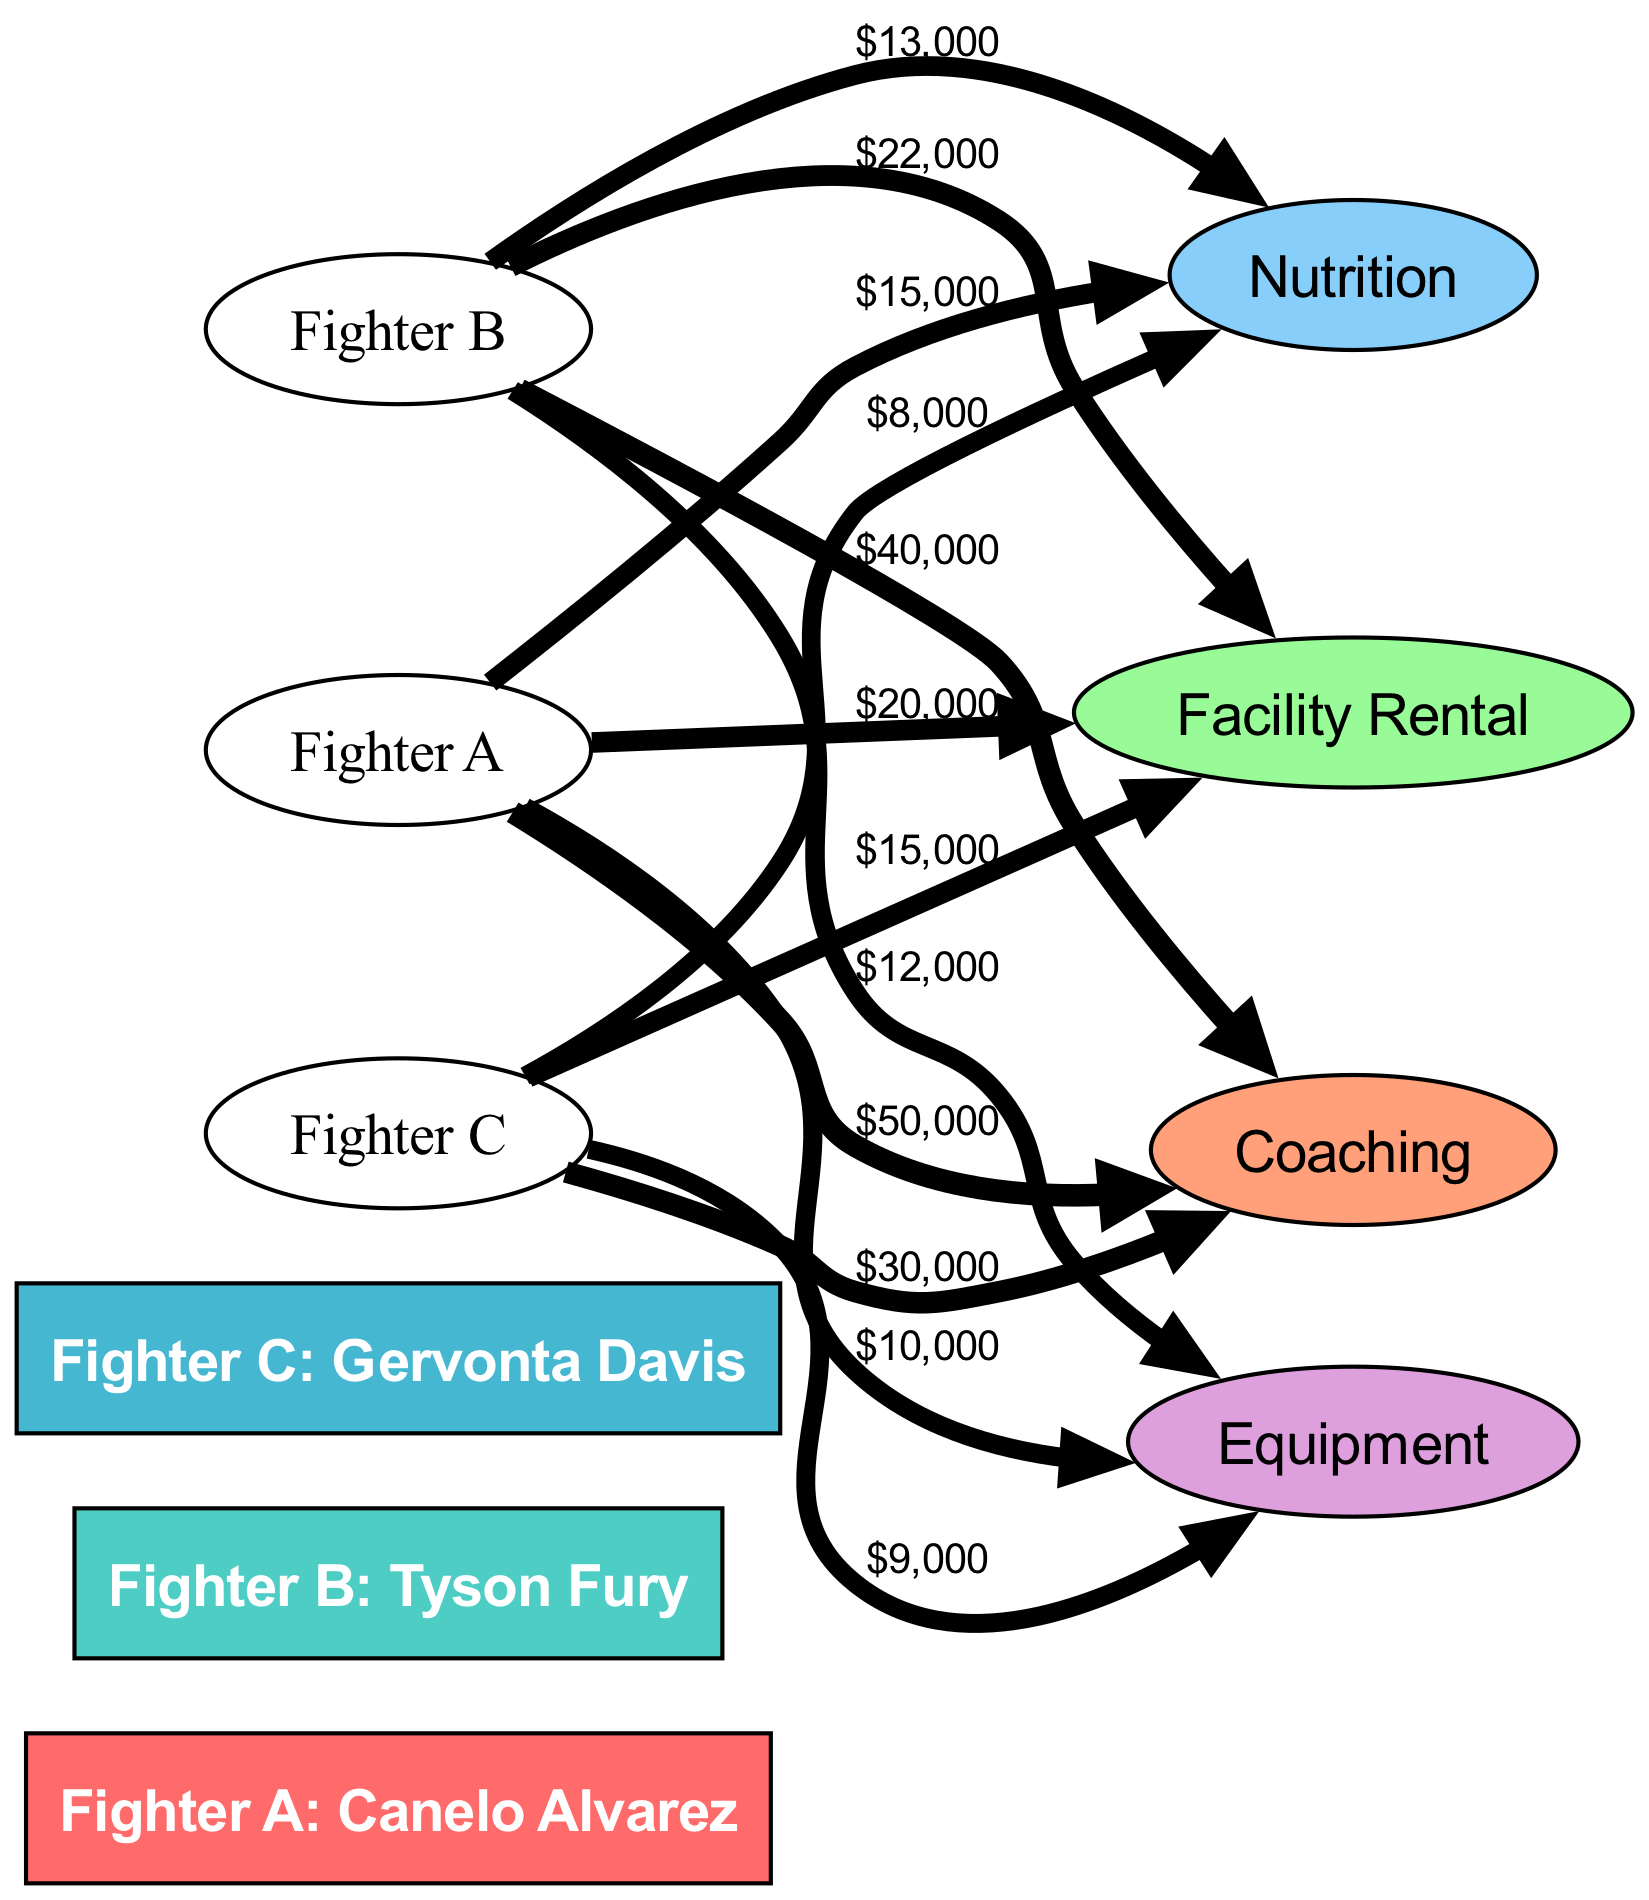What is the total expenditure for Fighter A? To find the total expenditure for Fighter A, add the values linked to Fighter A: Coaching ($50,000) + Facility Rental ($20,000) + Nutrition ($15,000) + Equipment ($10,000). This sums up to $50,000 + $20,000 + $15,000 + $10,000 = $95,000.
Answer: $95,000 Which fighter has the highest coaching expenditure? From the diagram, Fighter A has a coaching expenditure of $50,000, Fighter B has $40,000, and Fighter C has $30,000. The highest value comes from Fighter A at $50,000.
Answer: Fighter A: Canelo Alvarez What percentage of Fighter B's total expenditure is spent on Equipment? First, calculate Fighter B's total expenditure: Coaching ($40,000) + Facility Rental ($22,000) + Nutrition ($13,000) + Equipment ($12,000) = $87,000. Then, the Equipment expenditure is $12,000. The percentage is calculated as ($12,000 / $87,000) * 100 = 13.79%, which can be rounded to 13.8%.
Answer: 13.8% How much less does Gervonta Davis spend on Nutrition compared to Coaching? Gervonta Davis's Coaching expenditure is $30,000 and Nutrition expenditure is $8,000. To find the difference, subtract the Nutrition cost from the Coaching cost: $30,000 - $8,000 = $22,000.
Answer: $22,000 Which fighter has the lowest total expenditure? Calculate the total expenditure for each fighter: Fighter A: $95,000, Fighter B: $87,000, Fighter C: $66,000. Comparatively, Fighter C has the lowest total expenditure of $66,000.
Answer: Fighter C: Gervonta Davis What is the ratio of Nutrition costs for Fighter A to Fighter B? Check the Nutrition costs: Fighter A spends $15,000, and Fighter B spends $13,000. The ratio is $15,000 : $13,000, which simplifies to approximately 15:13 when expressed as a ratio.
Answer: 15:13 How many nodes represent the fighters in the diagram? The diagram has three fighter nodes: Fighter A (Canelo Alvarez), Fighter B (Tyson Fury), and Fighter C (Gervonta Davis). Thus, there are three nodes representing the fighters.
Answer: 3 What links have a value greater than $20,000? Review the links for their values: Fighter A: Coaching ($50,000), Facility Rental ($20,000), Nutrition ($15,000); Fighter B: Coaching ($40,000), Facility Rental ($22,000), Nutrition ($13,000); Fighter C: Coaching ($30,000), Facility Rental ($15,000), Nutrition ($8,000). The values greater than $20,000 are Coaching for Fighters A and B, Facility Rental for Fighter B, and Equipment for Fighter B. The total number is four links.
Answer: 4 What is the average Equipment cost for all fighters? Examine the Equipment costs: Fighter A spends $10,000, Fighter B spends $12,000, and Fighter C spends $9,000. The average is calculated as ($10,000 + $12,000 + $9,000) / 3 = $10,333.33, rounded to $10,333 for simplicity.
Answer: $10,333 